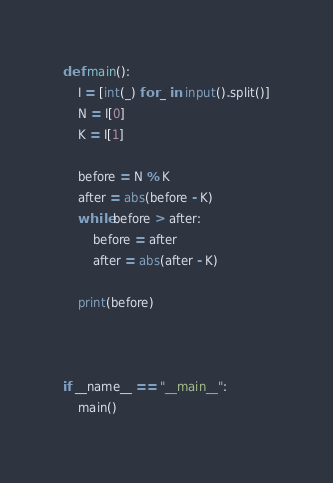Convert code to text. <code><loc_0><loc_0><loc_500><loc_500><_Python_>def main():
    I = [int(_) for _ in input().split()]
    N = I[0]
    K = I[1]

    before = N % K
    after = abs(before - K)
    while before > after:
        before = after
        after = abs(after - K)

    print(before)



if __name__ == "__main__":
    main()
</code> 